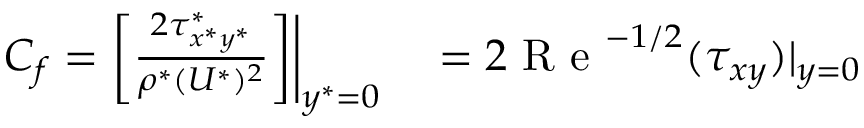<formula> <loc_0><loc_0><loc_500><loc_500>\begin{array} { r l } { C _ { f } = \Big [ \frac { 2 \tau _ { x ^ { * } y ^ { * } } ^ { * } } { \rho ^ { * } ( U ^ { * } ) ^ { 2 } } \Big ] \Big | _ { y ^ { * } = 0 } } & = 2 R e ^ { - 1 / 2 } ( \tau _ { x y } ) | _ { y = 0 } } \end{array}</formula> 